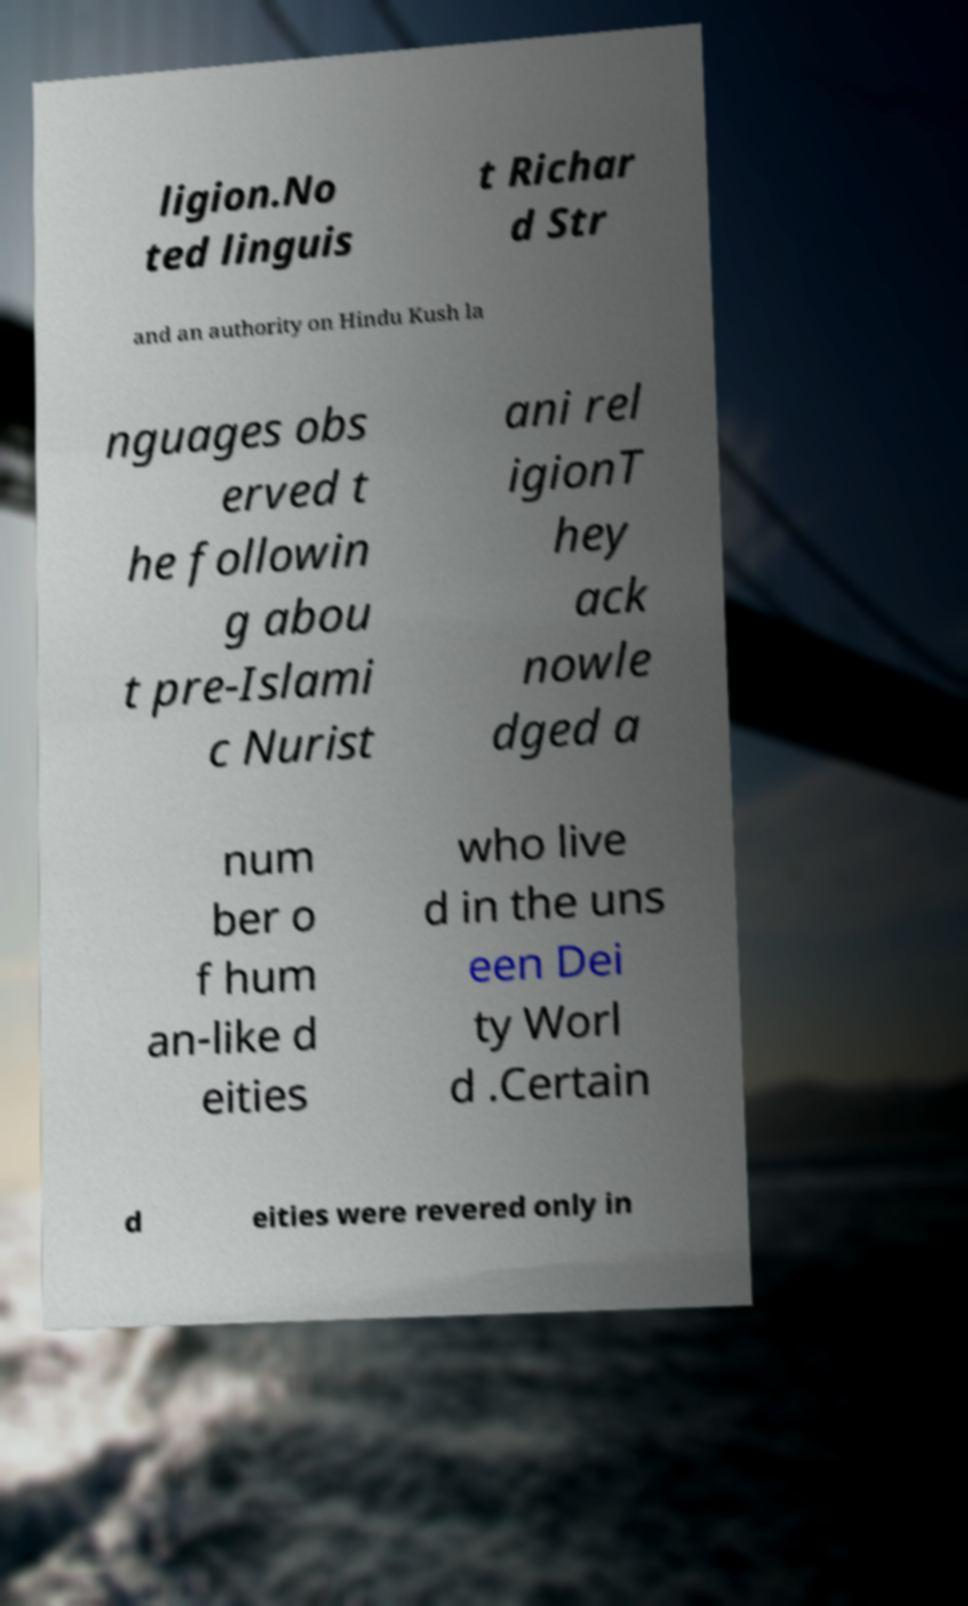Could you assist in decoding the text presented in this image and type it out clearly? ligion.No ted linguis t Richar d Str and an authority on Hindu Kush la nguages obs erved t he followin g abou t pre-Islami c Nurist ani rel igionT hey ack nowle dged a num ber o f hum an-like d eities who live d in the uns een Dei ty Worl d .Certain d eities were revered only in 